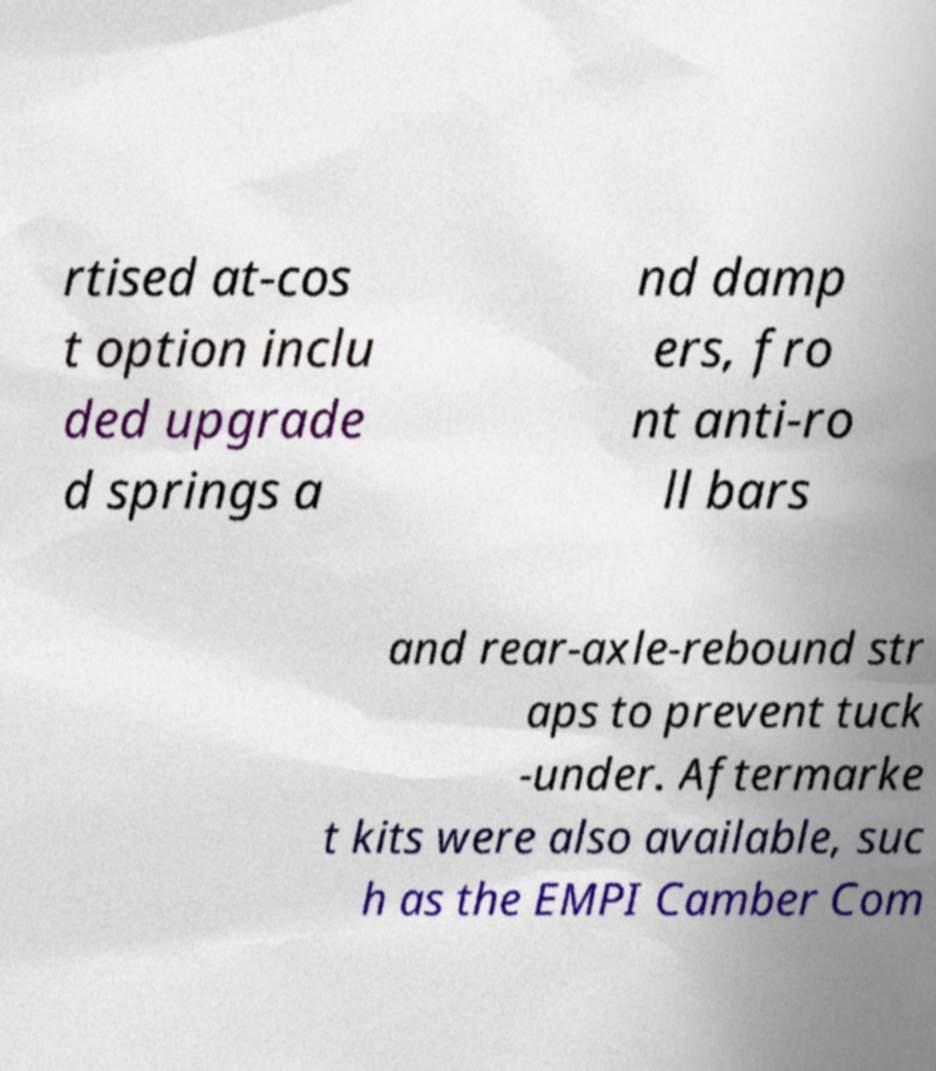Please read and relay the text visible in this image. What does it say? rtised at-cos t option inclu ded upgrade d springs a nd damp ers, fro nt anti-ro ll bars and rear-axle-rebound str aps to prevent tuck -under. Aftermarke t kits were also available, suc h as the EMPI Camber Com 